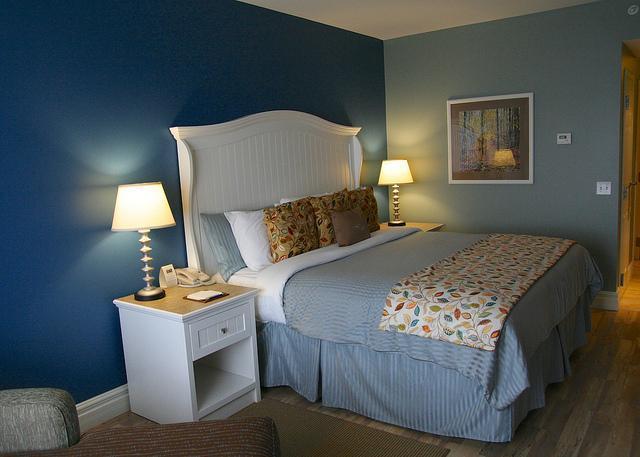How many paintings are there?
Give a very brief answer. 1. 